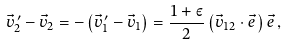Convert formula to latex. <formula><loc_0><loc_0><loc_500><loc_500>\vec { v } ^ { \, \prime } _ { 2 } - \vec { v } _ { 2 } = - \left ( \vec { v } ^ { \, \prime } _ { 1 } - \vec { v } _ { 1 } \right ) = \frac { 1 + \varepsilon } { 2 } \left ( \vec { v } _ { 1 2 } \cdot \vec { e } \, \right ) \vec { e } \, ,</formula> 